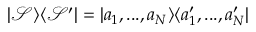Convert formula to latex. <formula><loc_0><loc_0><loc_500><loc_500>| \mathcal { S } \rangle \langle \mathcal { S } ^ { \prime } | = | a _ { 1 } , \dots , a _ { N } \rangle \langle a _ { 1 } ^ { \prime } , \dots , a _ { N } ^ { \prime } |</formula> 